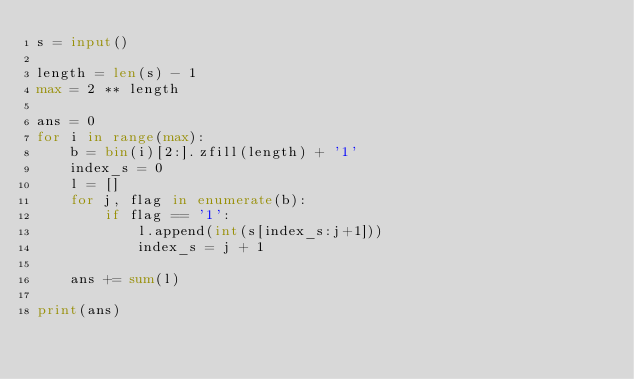<code> <loc_0><loc_0><loc_500><loc_500><_Python_>s = input()

length = len(s) - 1
max = 2 ** length

ans = 0
for i in range(max):
    b = bin(i)[2:].zfill(length) + '1'
    index_s = 0
    l = []
    for j, flag in enumerate(b):
        if flag == '1':
            l.append(int(s[index_s:j+1]))
            index_s = j + 1
    
    ans += sum(l)

print(ans)</code> 